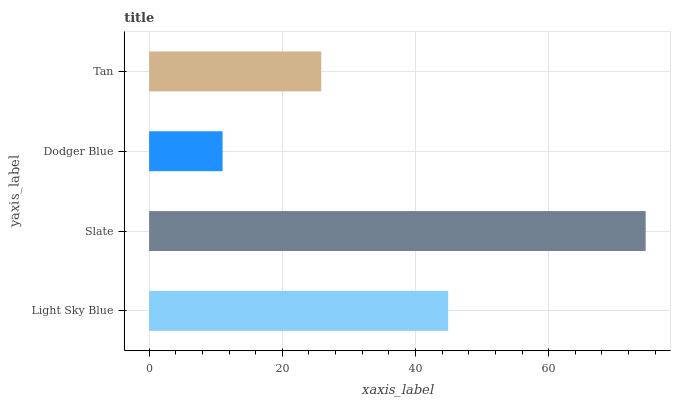Is Dodger Blue the minimum?
Answer yes or no. Yes. Is Slate the maximum?
Answer yes or no. Yes. Is Slate the minimum?
Answer yes or no. No. Is Dodger Blue the maximum?
Answer yes or no. No. Is Slate greater than Dodger Blue?
Answer yes or no. Yes. Is Dodger Blue less than Slate?
Answer yes or no. Yes. Is Dodger Blue greater than Slate?
Answer yes or no. No. Is Slate less than Dodger Blue?
Answer yes or no. No. Is Light Sky Blue the high median?
Answer yes or no. Yes. Is Tan the low median?
Answer yes or no. Yes. Is Dodger Blue the high median?
Answer yes or no. No. Is Light Sky Blue the low median?
Answer yes or no. No. 